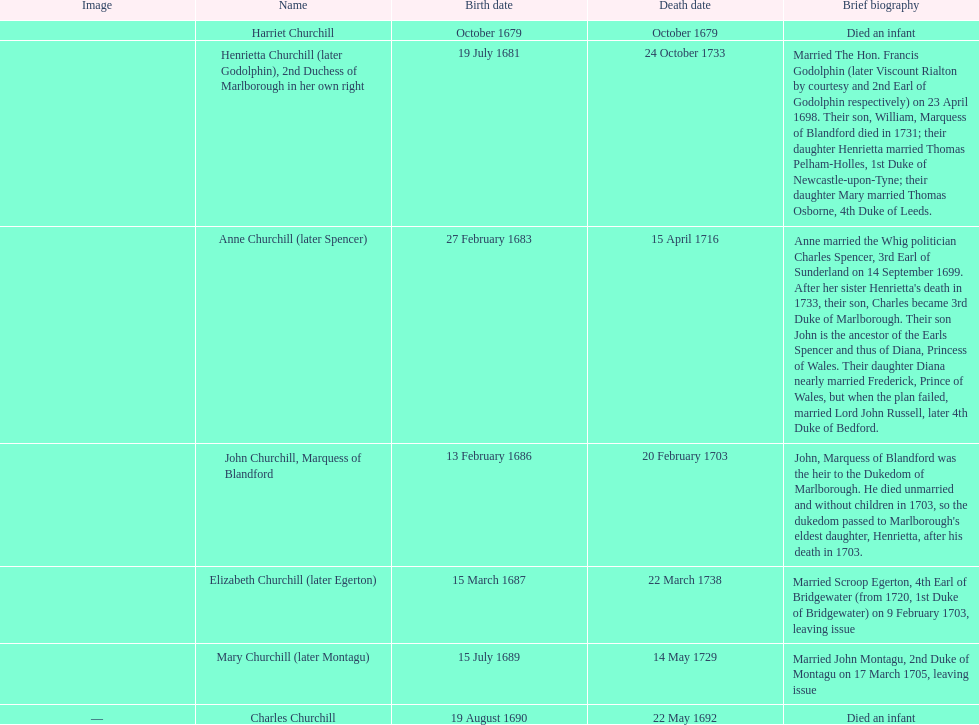Which churchill sibling was born first - mary or elizabeth? Elizabeth Churchill. 